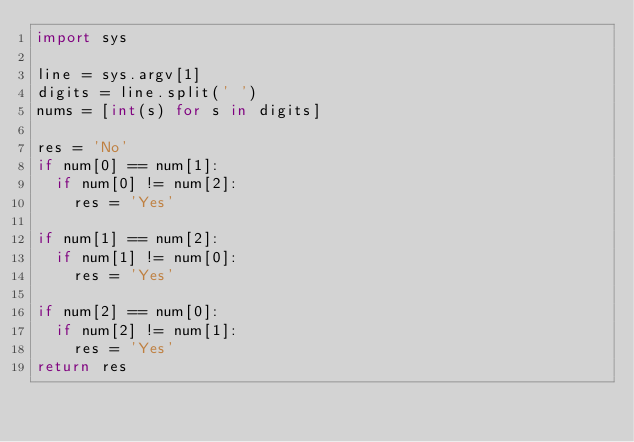Convert code to text. <code><loc_0><loc_0><loc_500><loc_500><_Python_>import sys

line = sys.argv[1]
digits = line.split(' ')
nums = [int(s) for s in digits]

res = 'No'
if num[0] == num[1]:
  if num[0] != num[2]:
    res = 'Yes'
    
if num[1] == num[2]:
  if num[1] != num[0]:
    res = 'Yes'
    
if num[2] == num[0]:
  if num[2] != num[1]:
    res = 'Yes'
return res</code> 